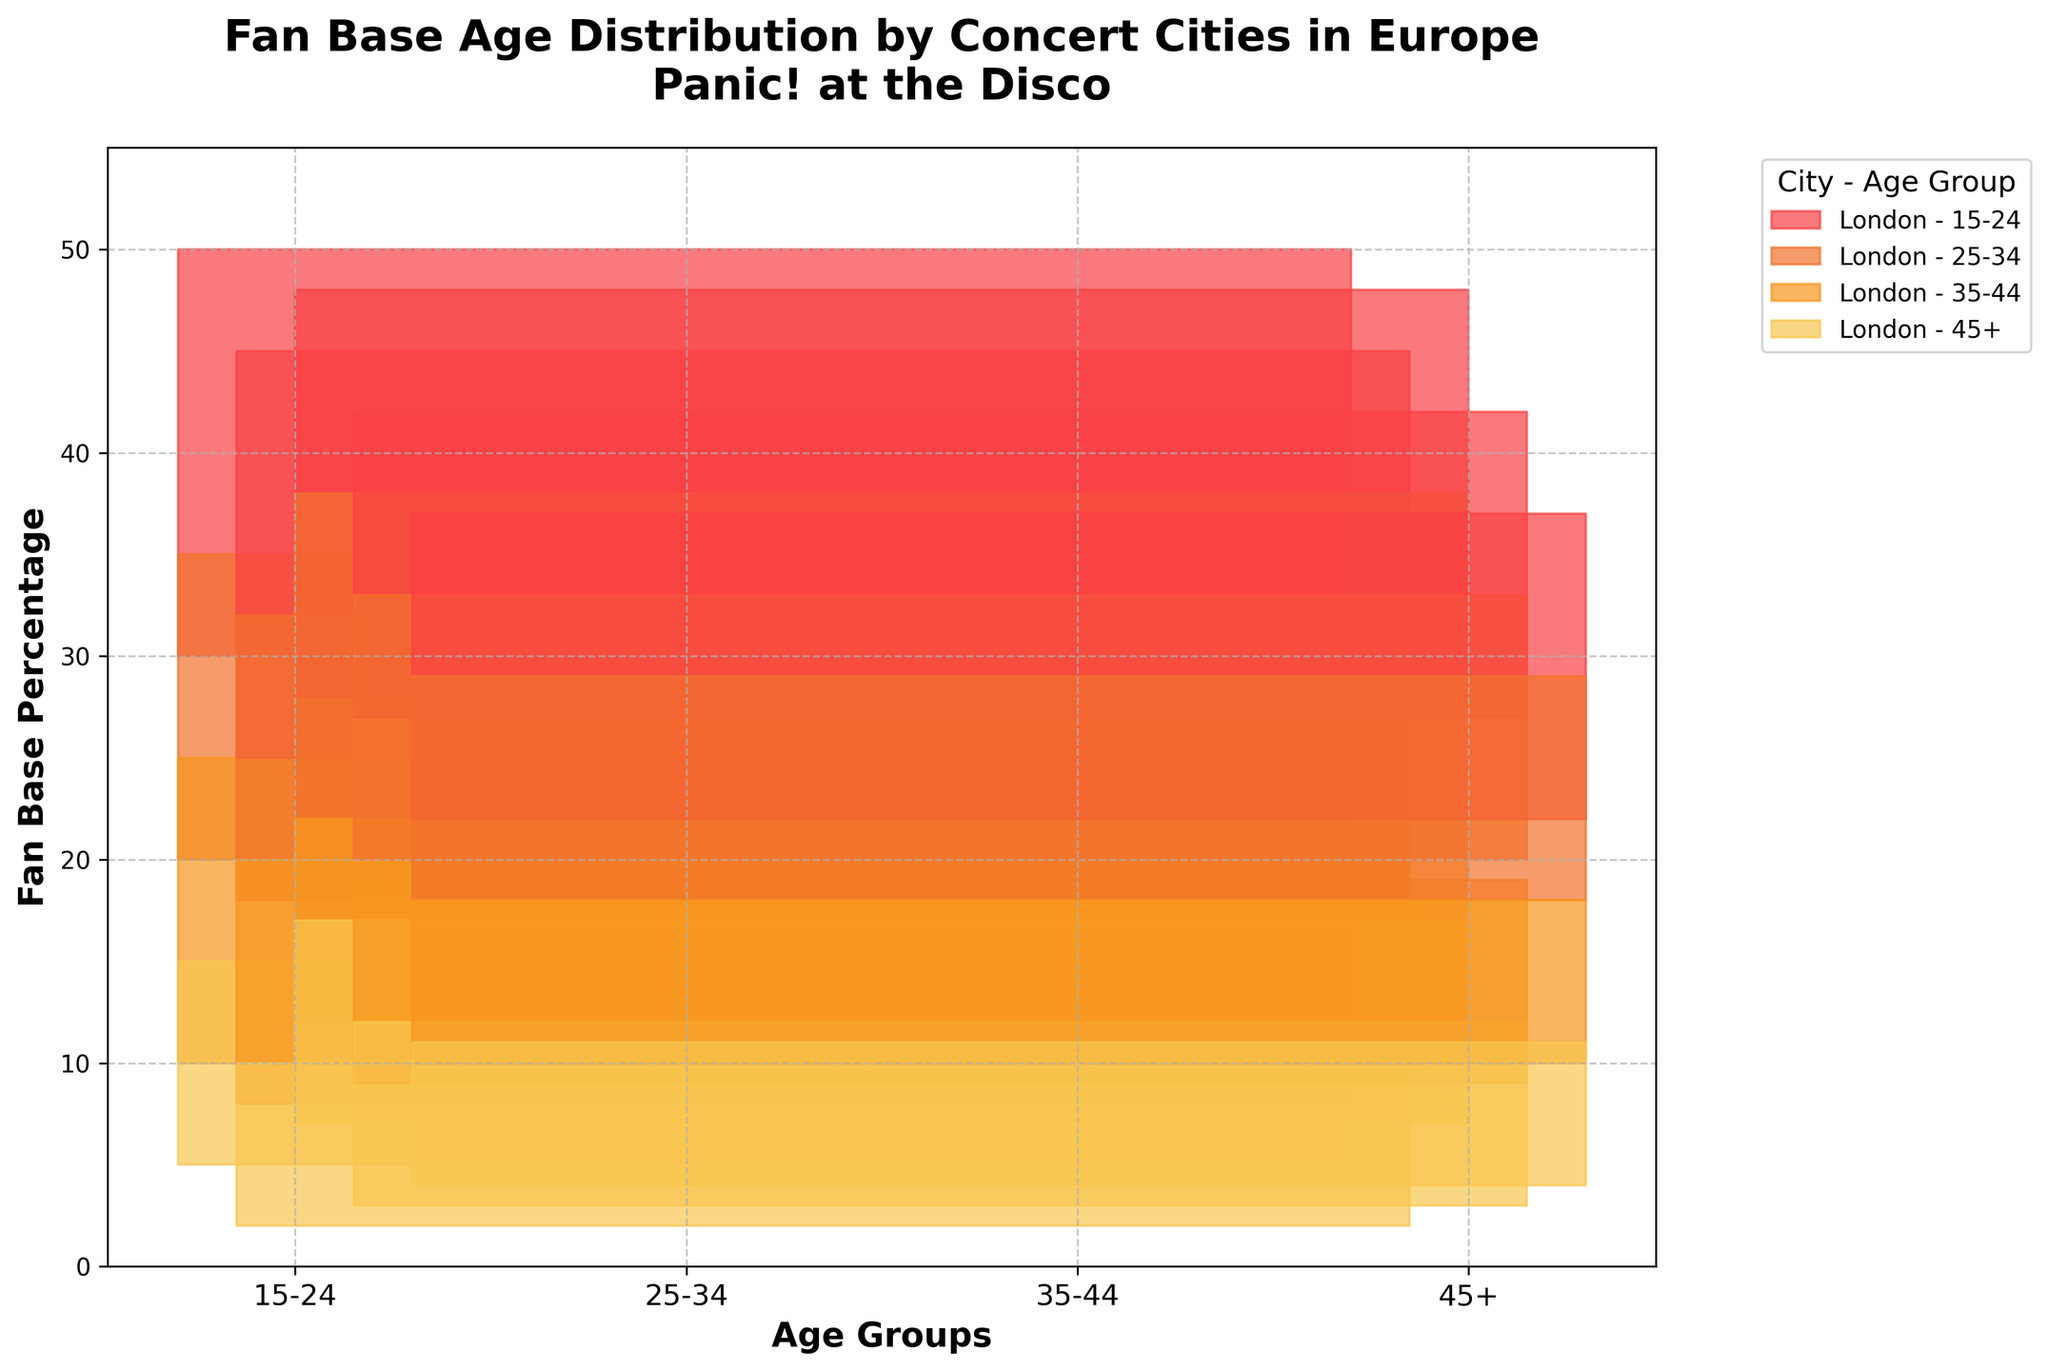What is the title of the figure? The title is displayed at the top of the chart and reads, "Fan Base Age Distribution by Concert Cities in Europe" followed by "Panic! at the Disco".
Answer: Fan Base Age Distribution by Concert Cities in Europe - Panic! at the Disco Which city has the highest upper range for the 15-24 age group? By looking at the colored bands for the 15-24 age group in each city, we see that Paris has the highest upper range, which is 48%.
Answer: Paris Which age group in Berlin has the smallest upper range? Looking at the upper ranges of each age group in Berlin, we observe that the 45+ age group has the smallest upper range of 10%.
Answer: 45+ Between Amsterdam and Madrid, which city has a higher lower range in the 25-34 age group? Comparing the lower ranges of the 25-34 age group between Amsterdam and Madrid, Amsterdam has 20%, while Madrid has 18%. Therefore, Amsterdam has the higher lower range.
Answer: Amsterdam What is the percentage range of the fan base age group 25-34 in London? The percentage range for the 25-34 age group in London is found between the lower range of 20% and the upper range of 35%.
Answer: 20%-35% Which city shows the narrowest age distribution range for the 35-44 age group? By comparing the range size (upper range minus lower range) for the 35-44 age group across all cities, Berlin has the smallest range of 12 - 8 = 4%.
Answer: Berlin If you combine the top 3 cities with the highest lower range for the 15-24 age group, what is the sum? Looking at the lower ranges for the 15-24 age group, we sum the top three values: London (30) + Paris (28) + Amsterdam (27) = 85%.
Answer: 85% Which city has the highest overall upper range for any age group? The highest overall upper range for any age group is found in Paris for the 15-24 age group with an upper range of 48%.
Answer: Paris How does the upper range of the 45+ age group in London compare to the same group in Paris? In London, the upper range for the 45+ age group is 15%, while in Paris it is 17%. Thus, Paris has a slightly higher upper range for this group.
Answer: Paris 